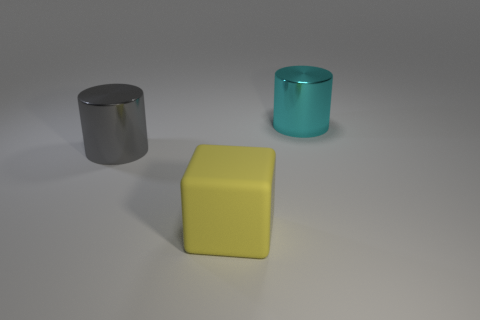Add 3 matte objects. How many objects exist? 6 Subtract all cylinders. How many objects are left? 1 Add 2 cylinders. How many cylinders are left? 4 Add 1 tiny gray shiny objects. How many tiny gray shiny objects exist? 1 Subtract 1 yellow blocks. How many objects are left? 2 Subtract all metal cylinders. Subtract all cyan rubber objects. How many objects are left? 1 